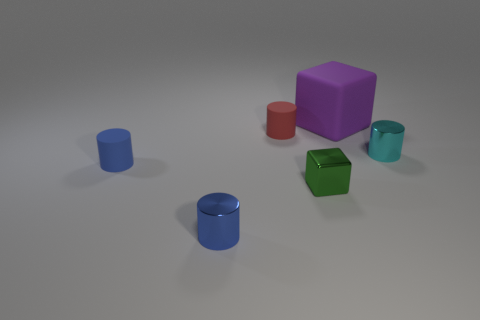Subtract all tiny blue rubber cylinders. How many cylinders are left? 3 Add 3 small yellow things. How many objects exist? 9 Subtract all brown blocks. How many blue cylinders are left? 2 Subtract all cubes. How many objects are left? 4 Subtract 1 cylinders. How many cylinders are left? 3 Subtract all cyan cylinders. How many cylinders are left? 3 Subtract all blocks. Subtract all large things. How many objects are left? 3 Add 2 tiny blue metal cylinders. How many tiny blue metal cylinders are left? 3 Add 1 small red cylinders. How many small red cylinders exist? 2 Subtract 0 yellow spheres. How many objects are left? 6 